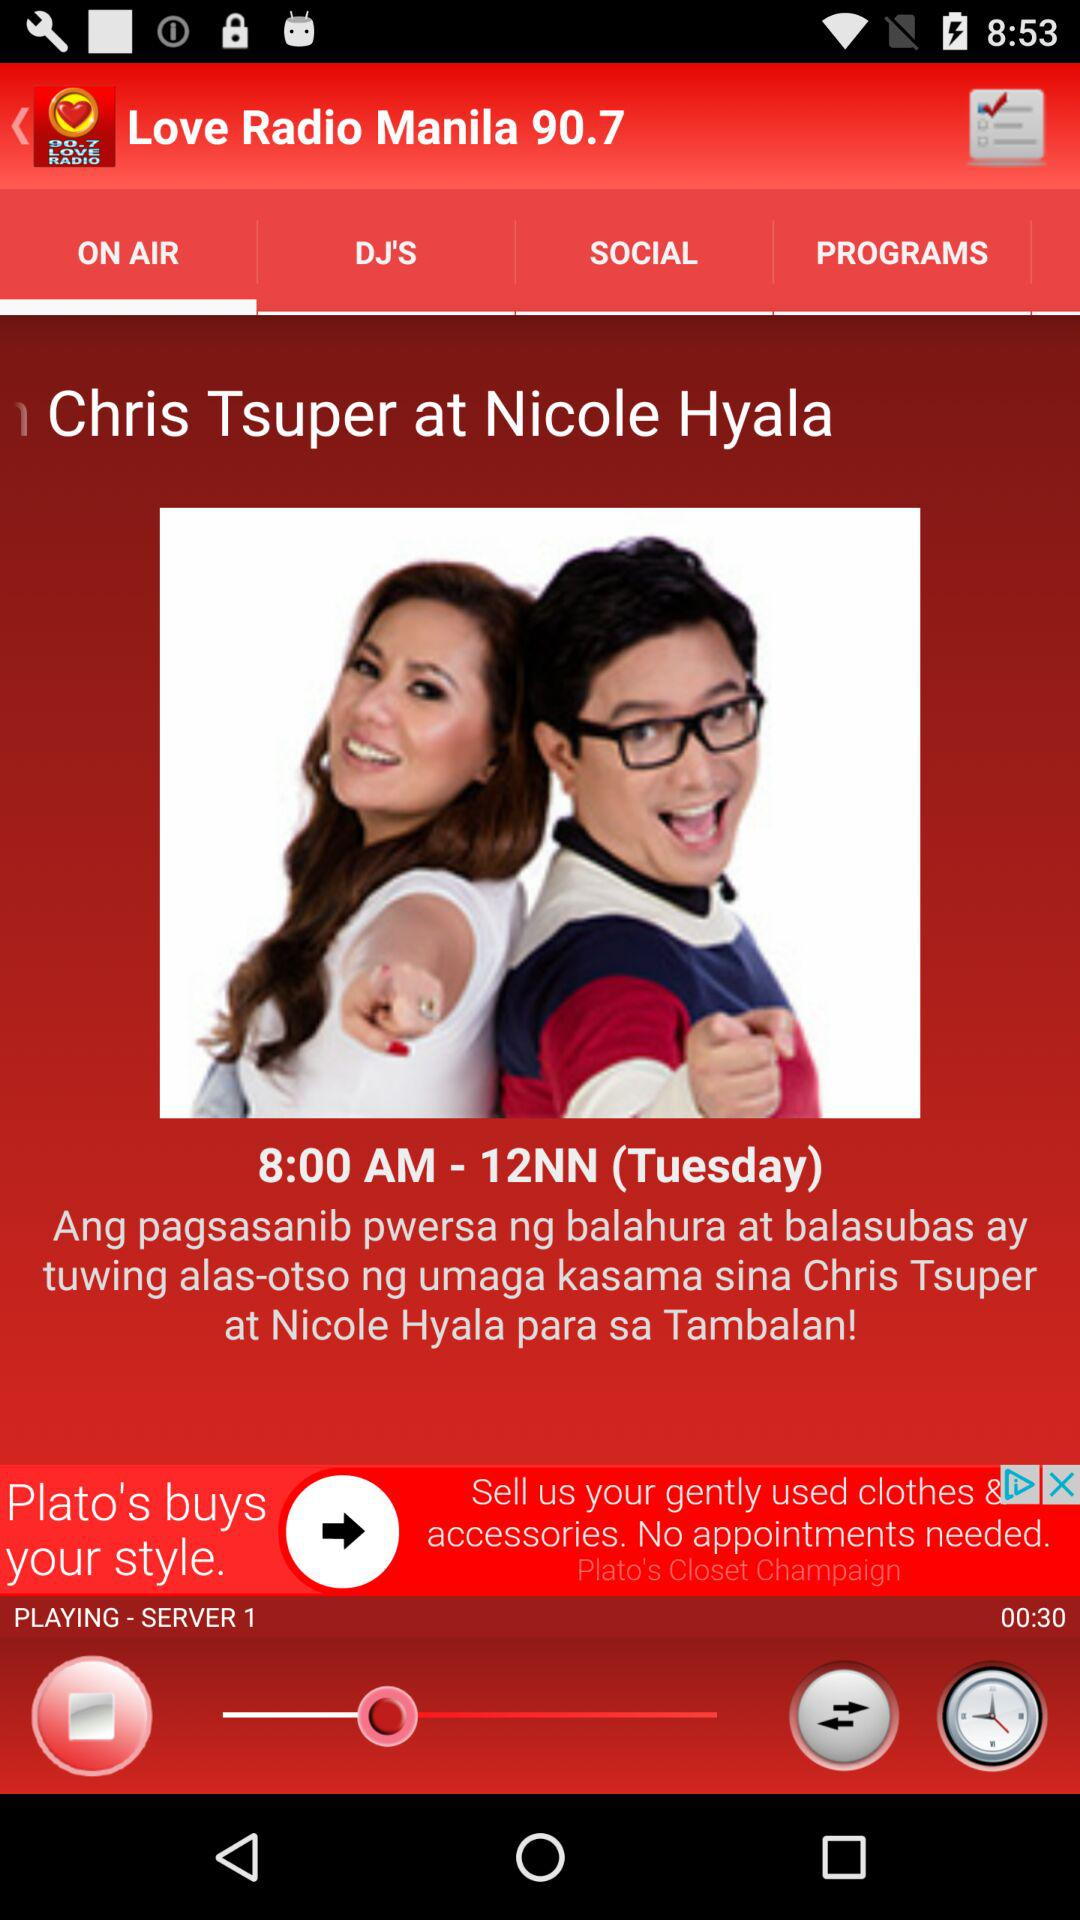Which is the selected tab? The selected tab is "ON AIR". 